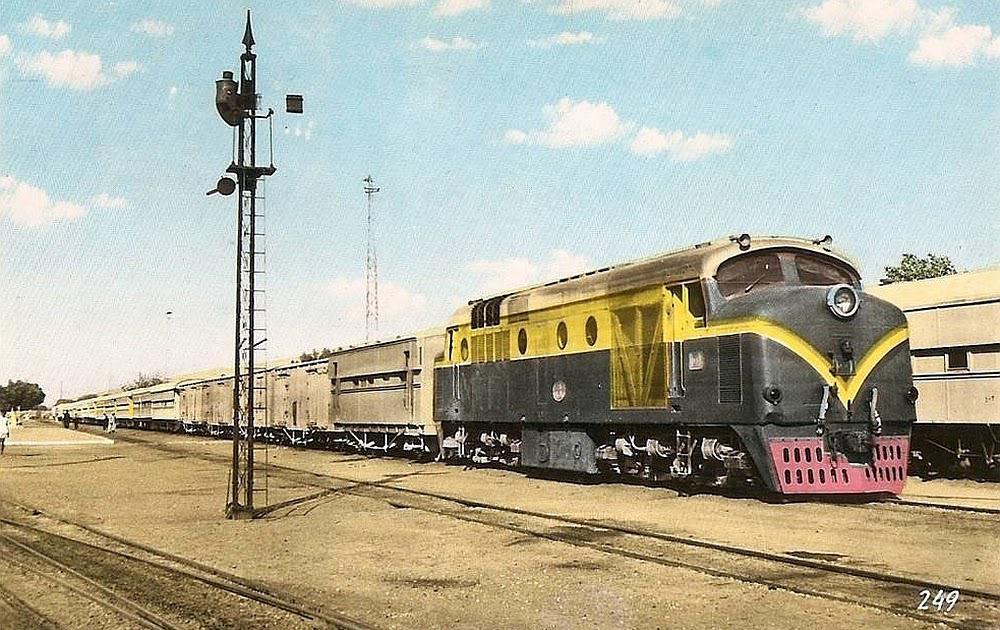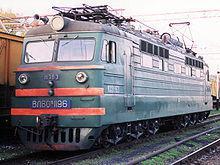The first image is the image on the left, the second image is the image on the right. Examine the images to the left and right. Is the description "The front car of a train is red-orange, and the train is shown at an angle heading down a straight track." accurate? Answer yes or no. No. The first image is the image on the left, the second image is the image on the right. For the images displayed, is the sentence "Exactly two locomotives are different colors and have different window designs, but are both headed in the same general direction and pulling a line of train cars." factually correct? Answer yes or no. No. 